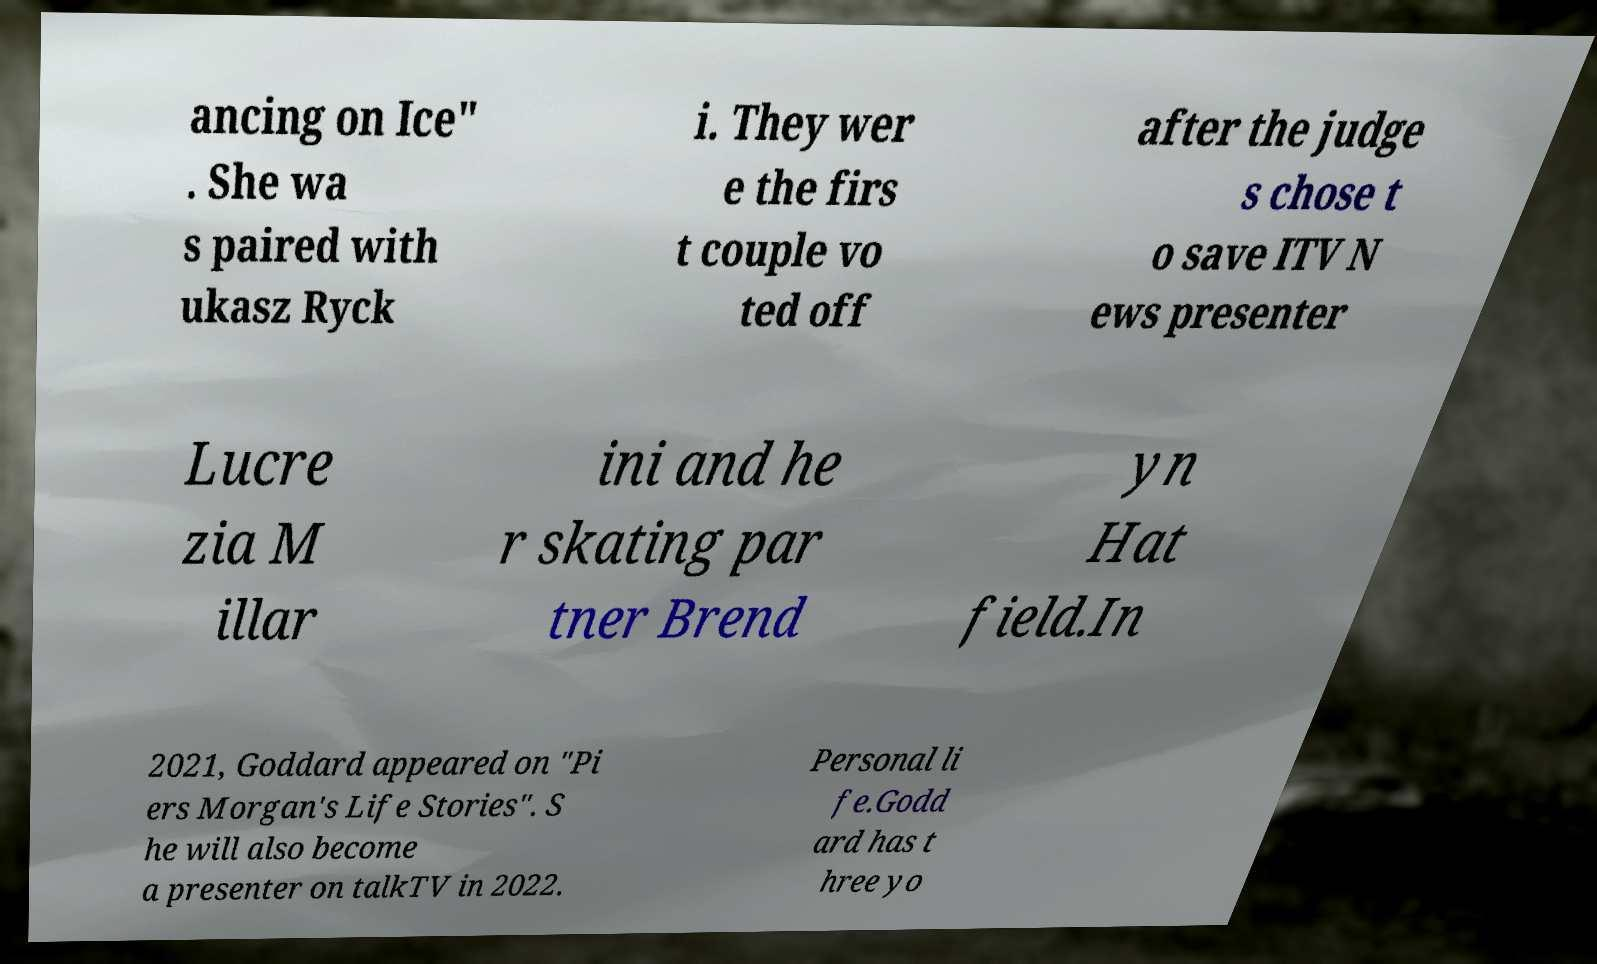Can you read and provide the text displayed in the image?This photo seems to have some interesting text. Can you extract and type it out for me? ancing on Ice" . She wa s paired with ukasz Ryck i. They wer e the firs t couple vo ted off after the judge s chose t o save ITV N ews presenter Lucre zia M illar ini and he r skating par tner Brend yn Hat field.In 2021, Goddard appeared on "Pi ers Morgan's Life Stories". S he will also become a presenter on talkTV in 2022. Personal li fe.Godd ard has t hree yo 